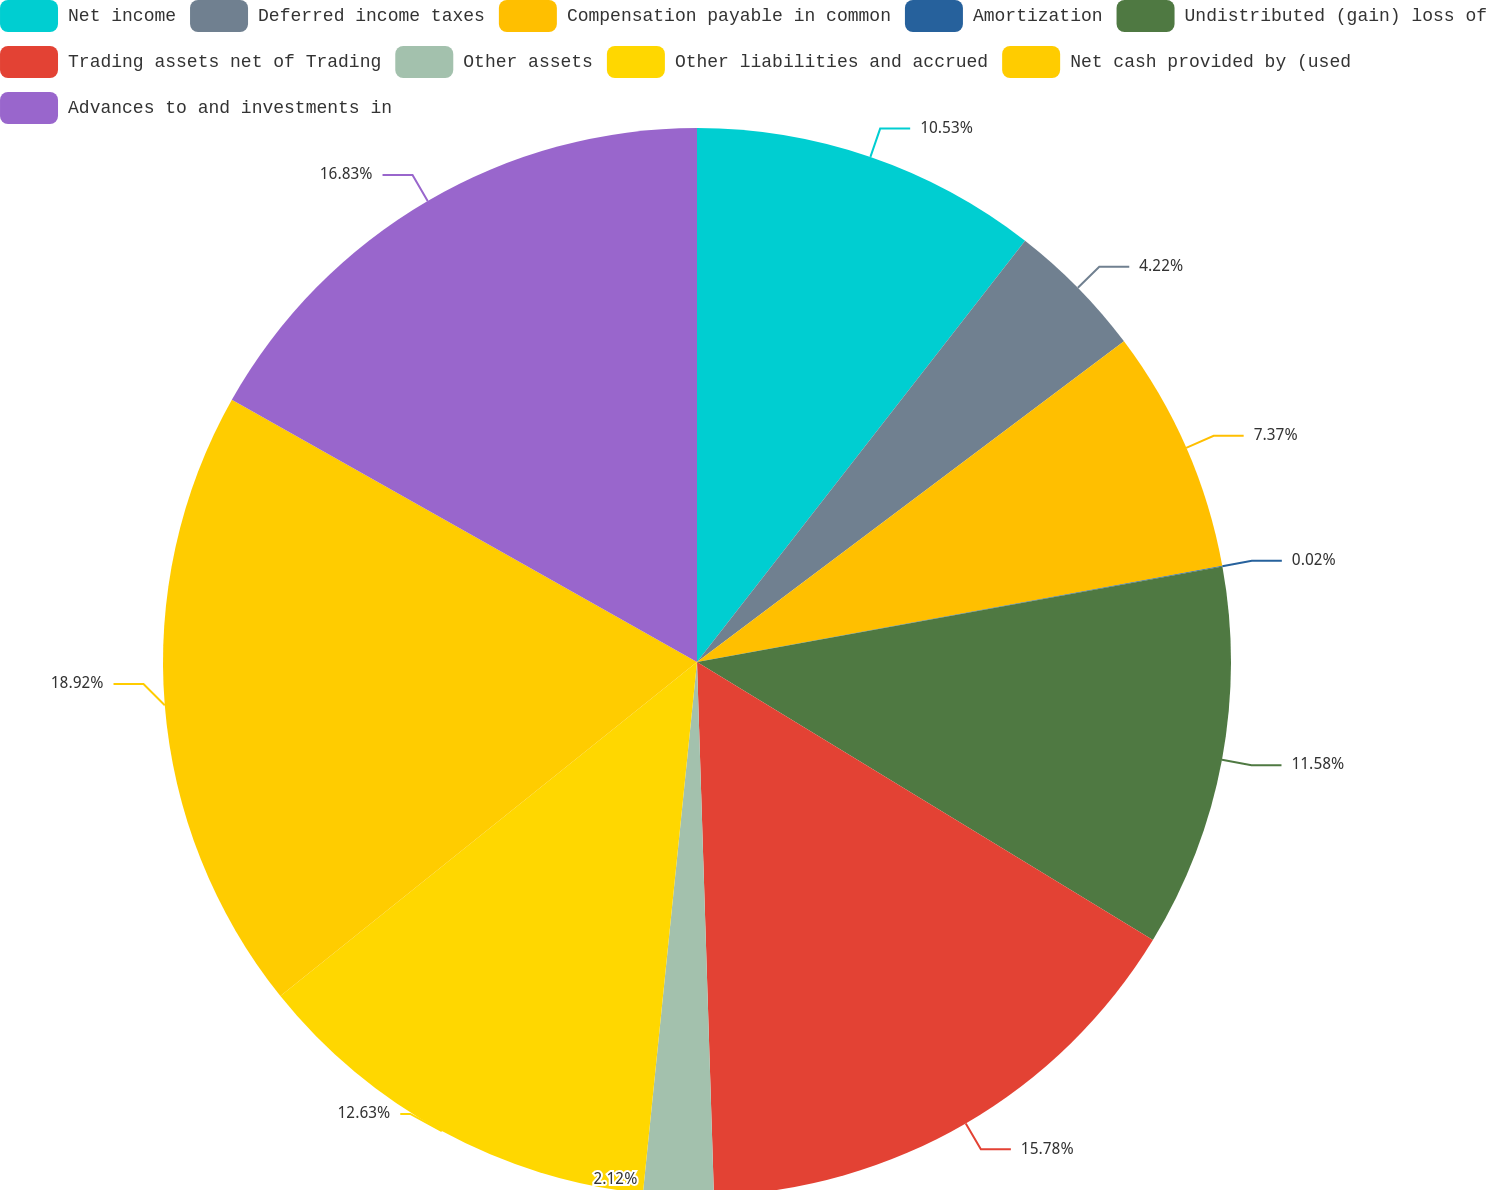Convert chart to OTSL. <chart><loc_0><loc_0><loc_500><loc_500><pie_chart><fcel>Net income<fcel>Deferred income taxes<fcel>Compensation payable in common<fcel>Amortization<fcel>Undistributed (gain) loss of<fcel>Trading assets net of Trading<fcel>Other assets<fcel>Other liabilities and accrued<fcel>Net cash provided by (used<fcel>Advances to and investments in<nl><fcel>10.53%<fcel>4.22%<fcel>7.37%<fcel>0.02%<fcel>11.58%<fcel>15.78%<fcel>2.12%<fcel>12.63%<fcel>18.93%<fcel>16.83%<nl></chart> 